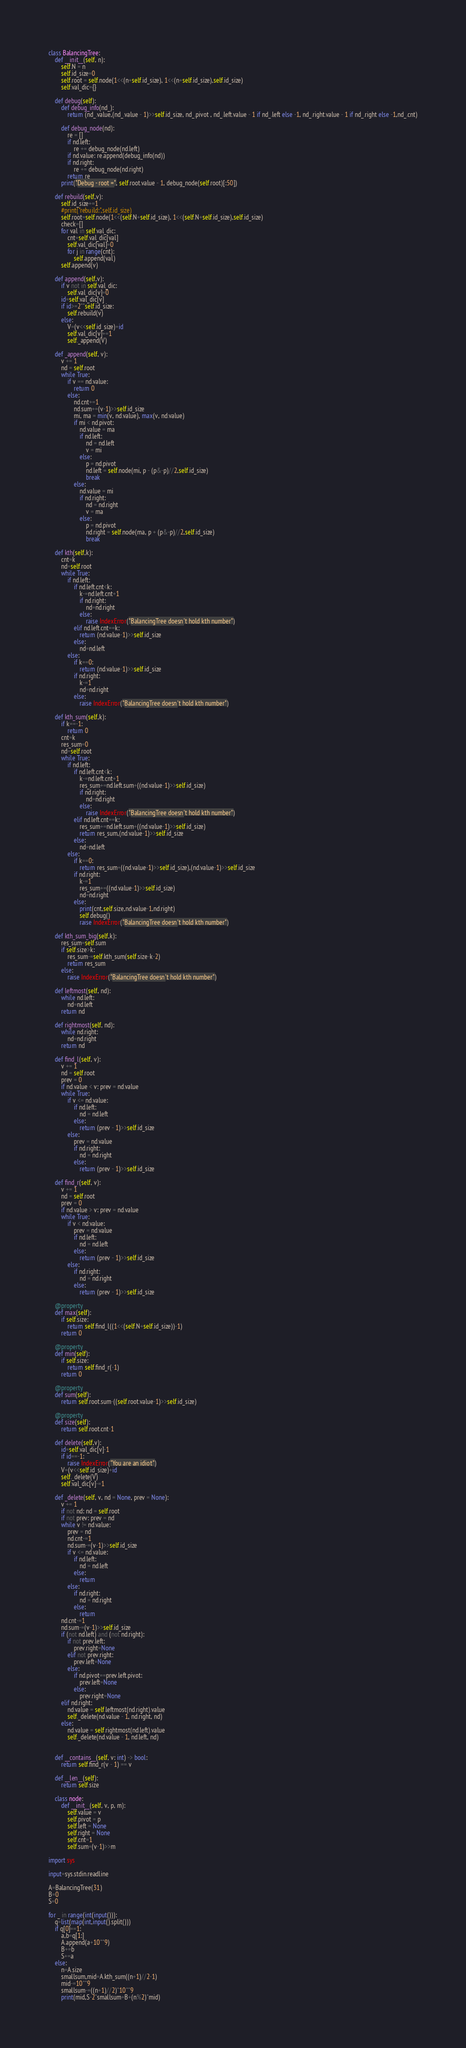Convert code to text. <code><loc_0><loc_0><loc_500><loc_500><_Python_>class BalancingTree:
    def __init__(self, n):
        self.N = n
        self.id_size=0
        self.root = self.node(1<<(n+self.id_size), 1<<(n+self.id_size),self.id_size)
        self.val_dic={}

    def debug(self):
        def debug_info(nd_):
            return (nd_.value,(nd_.value - 1)>>self.id_size, nd_.pivot , nd_.left.value - 1 if nd_.left else -1, nd_.right.value - 1 if nd_.right else -1,nd_.cnt)

        def debug_node(nd):
            re = []
            if nd.left:
                re += debug_node(nd.left)
            if nd.value: re.append(debug_info(nd))
            if nd.right:
                re += debug_node(nd.right)
            return re
        print("Debug - root =", self.root.value - 1, debug_node(self.root)[:50])

    def rebuild(self,v):
        self.id_size+=1
        #print("rebuild:",self.id_size)
        self.root=self.node(1<<(self.N+self.id_size), 1<<(self.N+self.id_size),self.id_size)
        check=[]
        for val in self.val_dic:
            cnt=self.val_dic[val]
            self.val_dic[val]=0
            for j in range(cnt):
                self.append(val)
        self.append(v)

    def append(self,v):
        if v not in self.val_dic:
            self.val_dic[v]=0
        id=self.val_dic[v]
        if id>=2**self.id_size:
            self.rebuild(v)
        else:
            V=(v<<self.id_size)+id
            self.val_dic[v]+=1
            self._append(V)

    def _append(self, v):
        v += 1
        nd = self.root
        while True:
            if v == nd.value:
                return 0
            else:
                nd.cnt+=1
                nd.sum+=(v-1)>>self.id_size
                mi, ma = min(v, nd.value), max(v, nd.value)
                if mi < nd.pivot:
                    nd.value = ma
                    if nd.left:
                        nd = nd.left
                        v = mi
                    else:
                        p = nd.pivot
                        nd.left = self.node(mi, p - (p&-p)//2,self.id_size)
                        break
                else:
                    nd.value = mi
                    if nd.right:
                        nd = nd.right
                        v = ma
                    else:
                        p = nd.pivot
                        nd.right = self.node(ma, p + (p&-p)//2,self.id_size)
                        break

    def kth(self,k):
        cnt=k
        nd=self.root
        while True:
            if nd.left:
                if nd.left.cnt<k:
                    k-=nd.left.cnt+1
                    if nd.right:
                        nd=nd.right
                    else:
                        raise IndexError("BalancingTree doesn't hold kth number")
                elif nd.left.cnt==k:
                    return (nd.value-1)>>self.id_size
                else:
                    nd=nd.left
            else:
                if k==0:
                    return (nd.value-1)>>self.id_size
                if nd.right:
                    k-=1
                    nd=nd.right
                else:
                    raise IndexError("BalancingTree doesn't hold kth number")

    def kth_sum(self,k):
        if k==-1:
            return 0
        cnt=k
        res_sum=0
        nd=self.root
        while True:
            if nd.left:
                if nd.left.cnt<k:
                    k-=nd.left.cnt+1
                    res_sum+=nd.left.sum+((nd.value-1)>>self.id_size)
                    if nd.right:
                        nd=nd.right
                    else:
                        raise IndexError("BalancingTree doesn't hold kth number")
                elif nd.left.cnt==k:
                    res_sum+=nd.left.sum+((nd.value-1)>>self.id_size)
                    return res_sum,(nd.value-1)>>self.id_size
                else:
                    nd=nd.left
            else:
                if k==0:
                    return res_sum+((nd.value-1)>>self.id_size),(nd.value-1)>>self.id_size
                if nd.right:
                    k-=1
                    res_sum+=((nd.value-1)>>self.id_size)
                    nd=nd.right
                else:
                    print(cnt,self.size,nd.value-1,nd.right)
                    self.debug()
                    raise IndexError("BalancingTree doesn't hold kth number")

    def kth_sum_big(self,k):
        res_sum=self.sum
        if self.size>k:
            res_sum-=self.kth_sum(self.size-k-2)
            return res_sum
        else:
            raise IndexError("BalancingTree doesn't hold kth number")

    def leftmost(self, nd):
        while nd.left:
            nd=nd.left
        return nd

    def rightmost(self, nd):
        while nd.right:
            nd=nd.right
        return nd

    def find_l(self, v):
        v += 1
        nd = self.root
        prev = 0
        if nd.value < v: prev = nd.value
        while True:
            if v <= nd.value:
                if nd.left:
                    nd = nd.left
                else:
                    return (prev - 1)>>self.id_size
            else:
                prev = nd.value
                if nd.right:
                    nd = nd.right
                else:
                    return (prev - 1)>>self.id_size

    def find_r(self, v):
        v += 1
        nd = self.root
        prev = 0
        if nd.value > v: prev = nd.value
        while True:
            if v < nd.value:
                prev = nd.value
                if nd.left:
                    nd = nd.left
                else:
                    return (prev - 1)>>self.id_size
            else:
                if nd.right:
                    nd = nd.right
                else:
                    return (prev - 1)>>self.id_size

    @property
    def max(self):
        if self.size:
            return self.find_l((1<<(self.N+self.id_size))-1)
        return 0

    @property
    def min(self):
        if self.size:
            return self.find_r(-1)
        return 0

    @property
    def sum(self):
        return self.root.sum-((self.root.value-1)>>self.id_size)

    @property
    def size(self):
        return self.root.cnt-1

    def delete(self,v):
        id=self.val_dic[v]-1
        if id==-1:
            raise IndexError("You are an idiot")
        V=(v<<self.id_size)+id
        self._delete(V)
        self.val_dic[v]-=1

    def _delete(self, v, nd = None, prev = None):
        v += 1
        if not nd: nd = self.root
        if not prev: prev = nd
        while v != nd.value:
            prev = nd
            nd.cnt-=1
            nd.sum-=(v-1)>>self.id_size
            if v <= nd.value:
                if nd.left:
                    nd = nd.left
                else:
                    return
            else:
                if nd.right:
                    nd = nd.right
                else:
                    return
        nd.cnt-=1
        nd.sum-=(v-1)>>self.id_size
        if (not nd.left) and (not nd.right):
            if not prev.left:
                prev.right=None
            elif not prev.right:
                prev.left=None
            else:
                if nd.pivot==prev.left.pivot:
                    prev.left=None
                else:
                    prev.right=None
        elif nd.right:
            nd.value = self.leftmost(nd.right).value
            self._delete(nd.value - 1, nd.right, nd)
        else:
            nd.value = self.rightmost(nd.left).value
            self._delete(nd.value - 1, nd.left, nd)


    def __contains__(self, v: int) -> bool:
        return self.find_r(v - 1) == v

    def __len__(self):
        return self.size

    class node:
        def __init__(self, v, p, m):
            self.value = v
            self.pivot = p
            self.left = None
            self.right = None
            self.cnt=1
            self.sum=(v-1)>>m

import sys

input=sys.stdin.readline

A=BalancingTree(31)
B=0
S=0

for _ in range(int(input())):
    q=list(map(int,input().split()))
    if q[0]==1:
        a,b=q[1:]
        A.append(a+10**9)
        B+=b
        S+=a
    else:
        n=A.size
        smallsum,mid=A.kth_sum((n+1)//2-1)
        mid-=10**9
        smallsum-=((n+1)//2)*10**9
        print(mid,S-2*smallsum+B+(n%2)*mid)</code> 